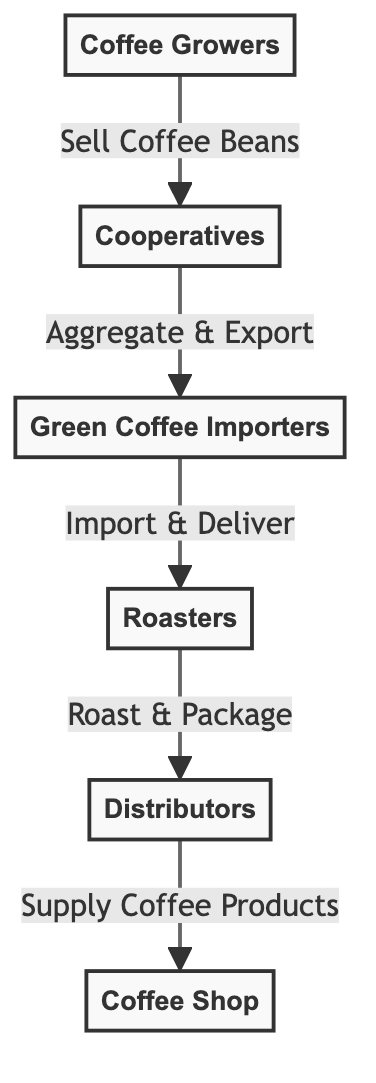What is the first node in the supply chain? The first node in the supply chain is "Coffee Growers," as it is the starting point where coffee is produced before any further processing or selling occurs.
Answer: Coffee Growers How many nodes are present in the diagram? There are six nodes in the diagram: Coffee Growers, Cooperatives, Green Coffee Importers, Roasters, Distributors, and Coffee Shop. Counting them gives a total of six distinct entities involved in the supply chain.
Answer: 6 Who does the "Cooperatives" sell the coffee beans to? The "Cooperatives" sell the coffee beans to "Green Coffee Importers," as indicated by the directed arrow showing the flow from Cooperatives to Importers.
Answer: Green Coffee Importers What is the role of "Roasters" in the supply chain? The role of "Roasters" is to roast and package coffee, as indicated by the label on the edge leading from "Roasters" to "Distributors." This establishes that they prepare the coffee for distribution.
Answer: Roast & Package Which node comes directly before the "Coffee Shop" in the supply chain? The node directly before the "Coffee Shop" is "Distributors," as it supplies the coffee products (from Roasters) to the shop, forming the last step in the chain before reaching the consumer.
Answer: Distributors What action do "Green Coffee Importers" take regarding the coffee? "Green Coffee Importers" perform the action of import and deliver coffee, as shown by the direction and label of the flow from Importers to Roasters, indicating their role in bringing coffee into the country.
Answer: Import & Deliver What is the relationship between "Distributors" and "Coffee Shop"? The relationship is that "Distributors" supply coffee products to the "Coffee Shop," enabling the shop to provide coffee to consumers. This relationship is established by the directed edge connecting these two nodes.
Answer: Supply Coffee Products How many connections does "Coffee Growers" have? "Coffee Growers" has one direct connection to "Cooperatives," as it is the only entity to which they sell coffee beans, indicating a one-way flow from Growers to Cooperatives.
Answer: 1 